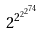Convert formula to latex. <formula><loc_0><loc_0><loc_500><loc_500>2 ^ { 2 ^ { 2 ^ { 2 ^ { 7 4 } } } }</formula> 